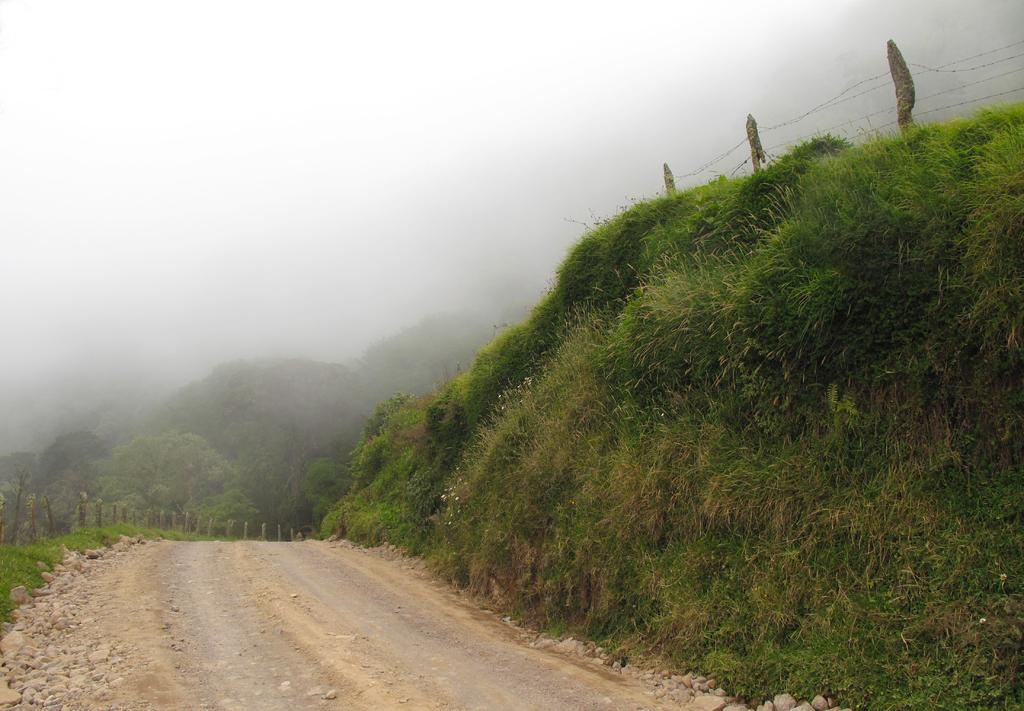What is the main feature in the center of the image? There is a road in the center of the image. What type of vegetation is on the left side of the image? There is grass on the left side of the image. What can be seen in the background of the image? There are trees in the background of the image. What brand of toothpaste is advertised on the road in the image? There is no toothpaste or advertisement present in the image. How does the grandfather interact with the road in the image? There is no grandfather present in the image. 